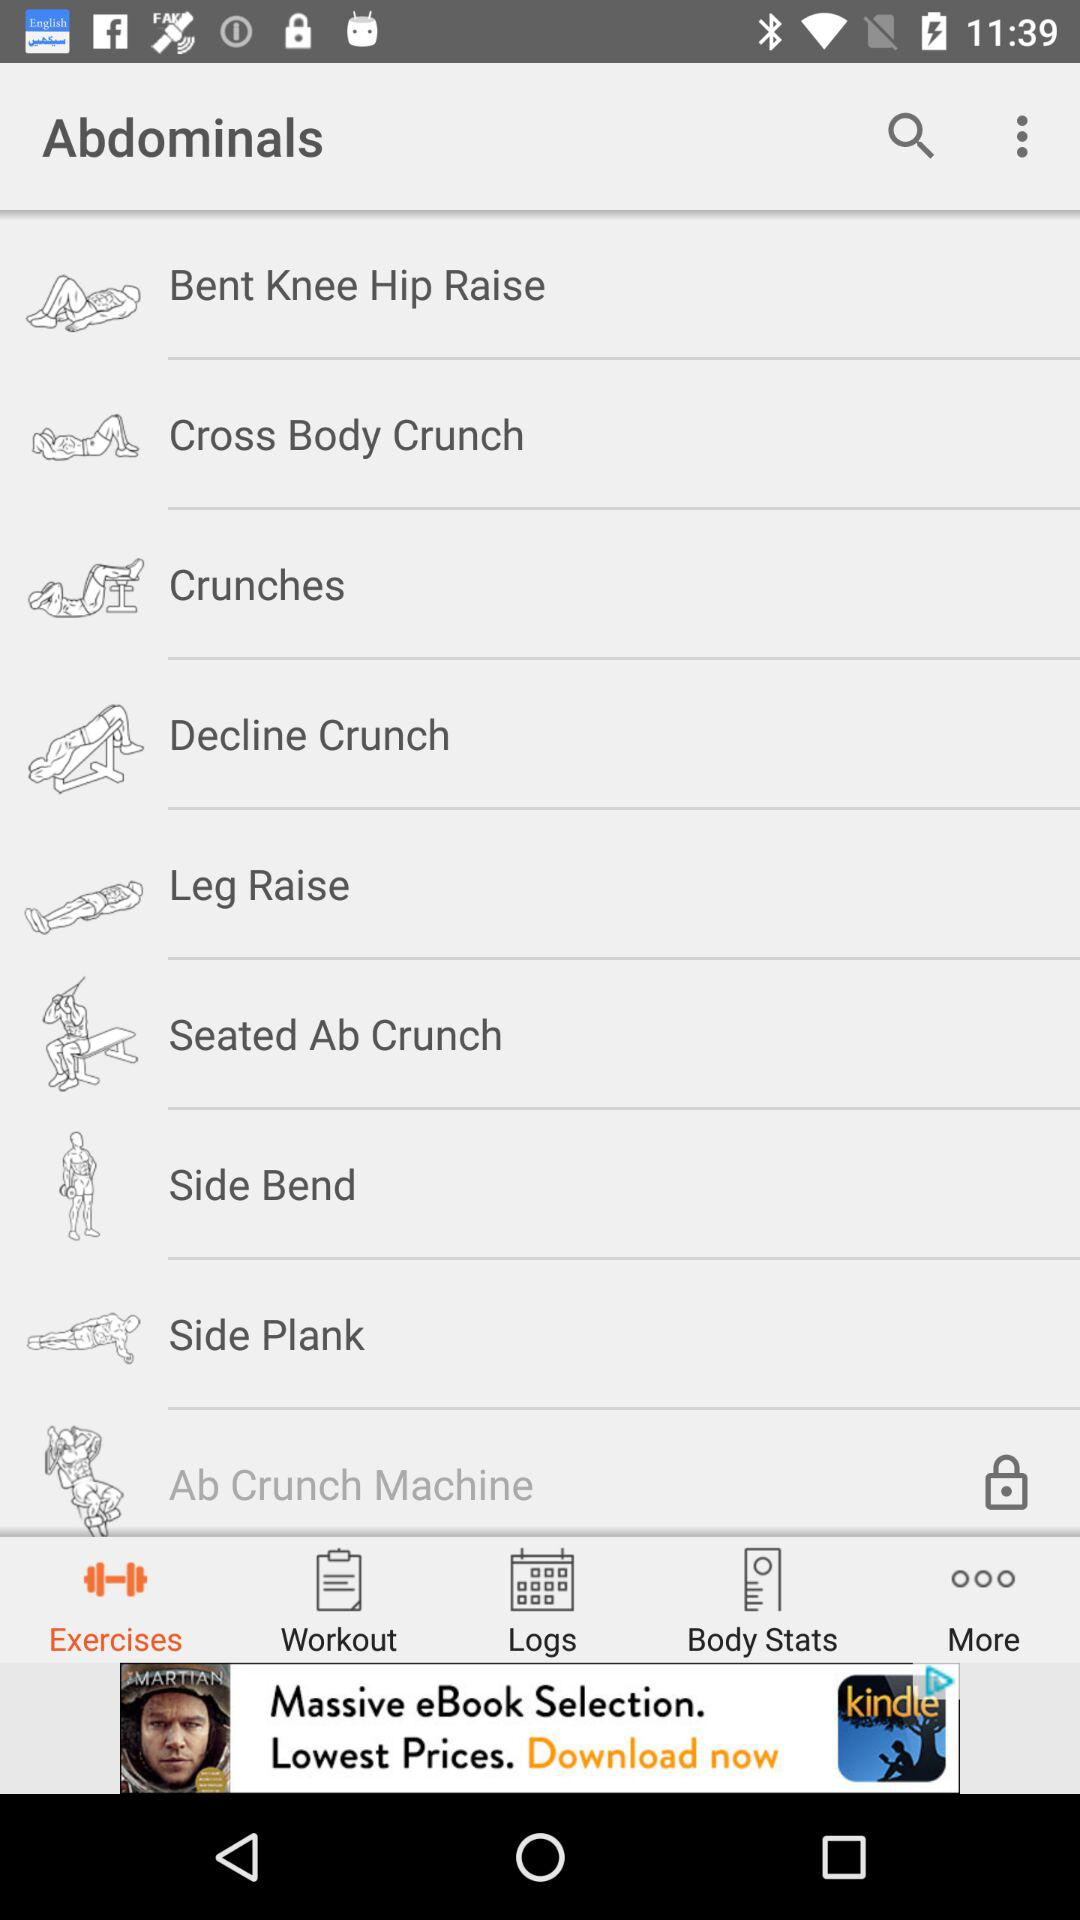What is the selected tab? The selected tab is "Exercises". 